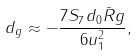Convert formula to latex. <formula><loc_0><loc_0><loc_500><loc_500>d _ { g } \approx - \frac { 7 S _ { 7 } d _ { 0 } \bar { R } g } { 6 u _ { 1 } ^ { 2 } } ,</formula> 